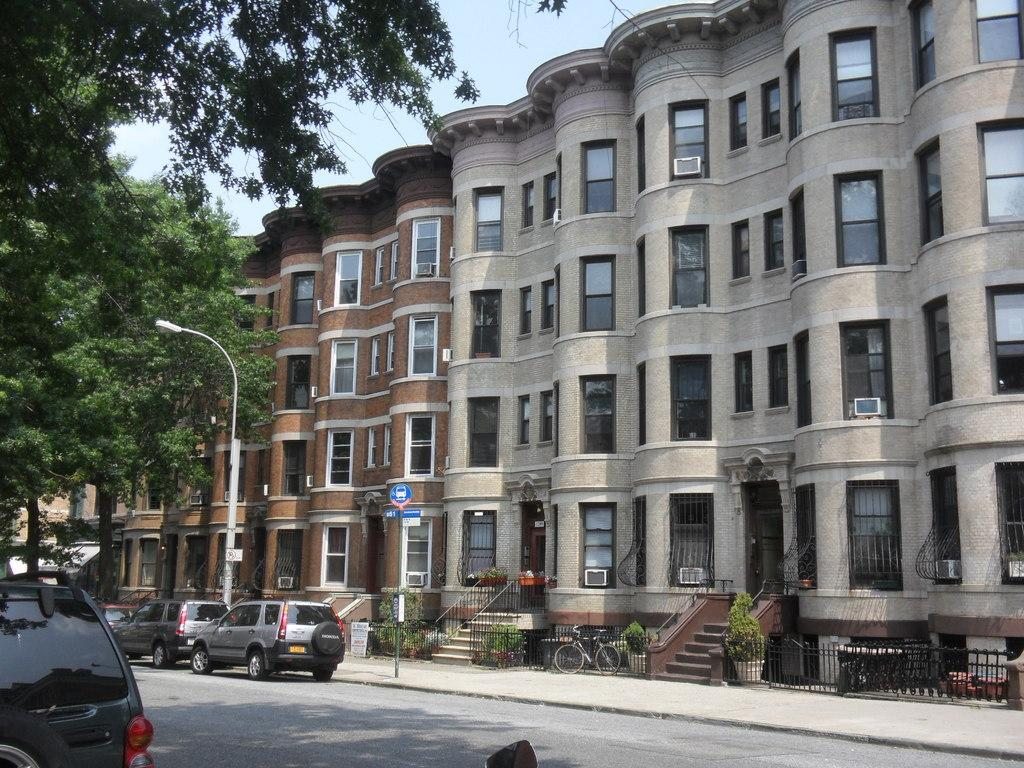What can be seen on the road in the image? There are vehicles on the road in the image. What is visible in the background of the image? The sky, trees, buildings, poles, plant pots, fences, and sign boards are visible in the background of the image. Are there any structures visible in the background of the image? Yes, there are buildings and staircases visible in the background of the image. What type of religious symbol can be seen on the vehicles in the image? There is no religious symbol visible on the vehicles in the image. Is there a writer present in the image? There is no writer present in the image. 